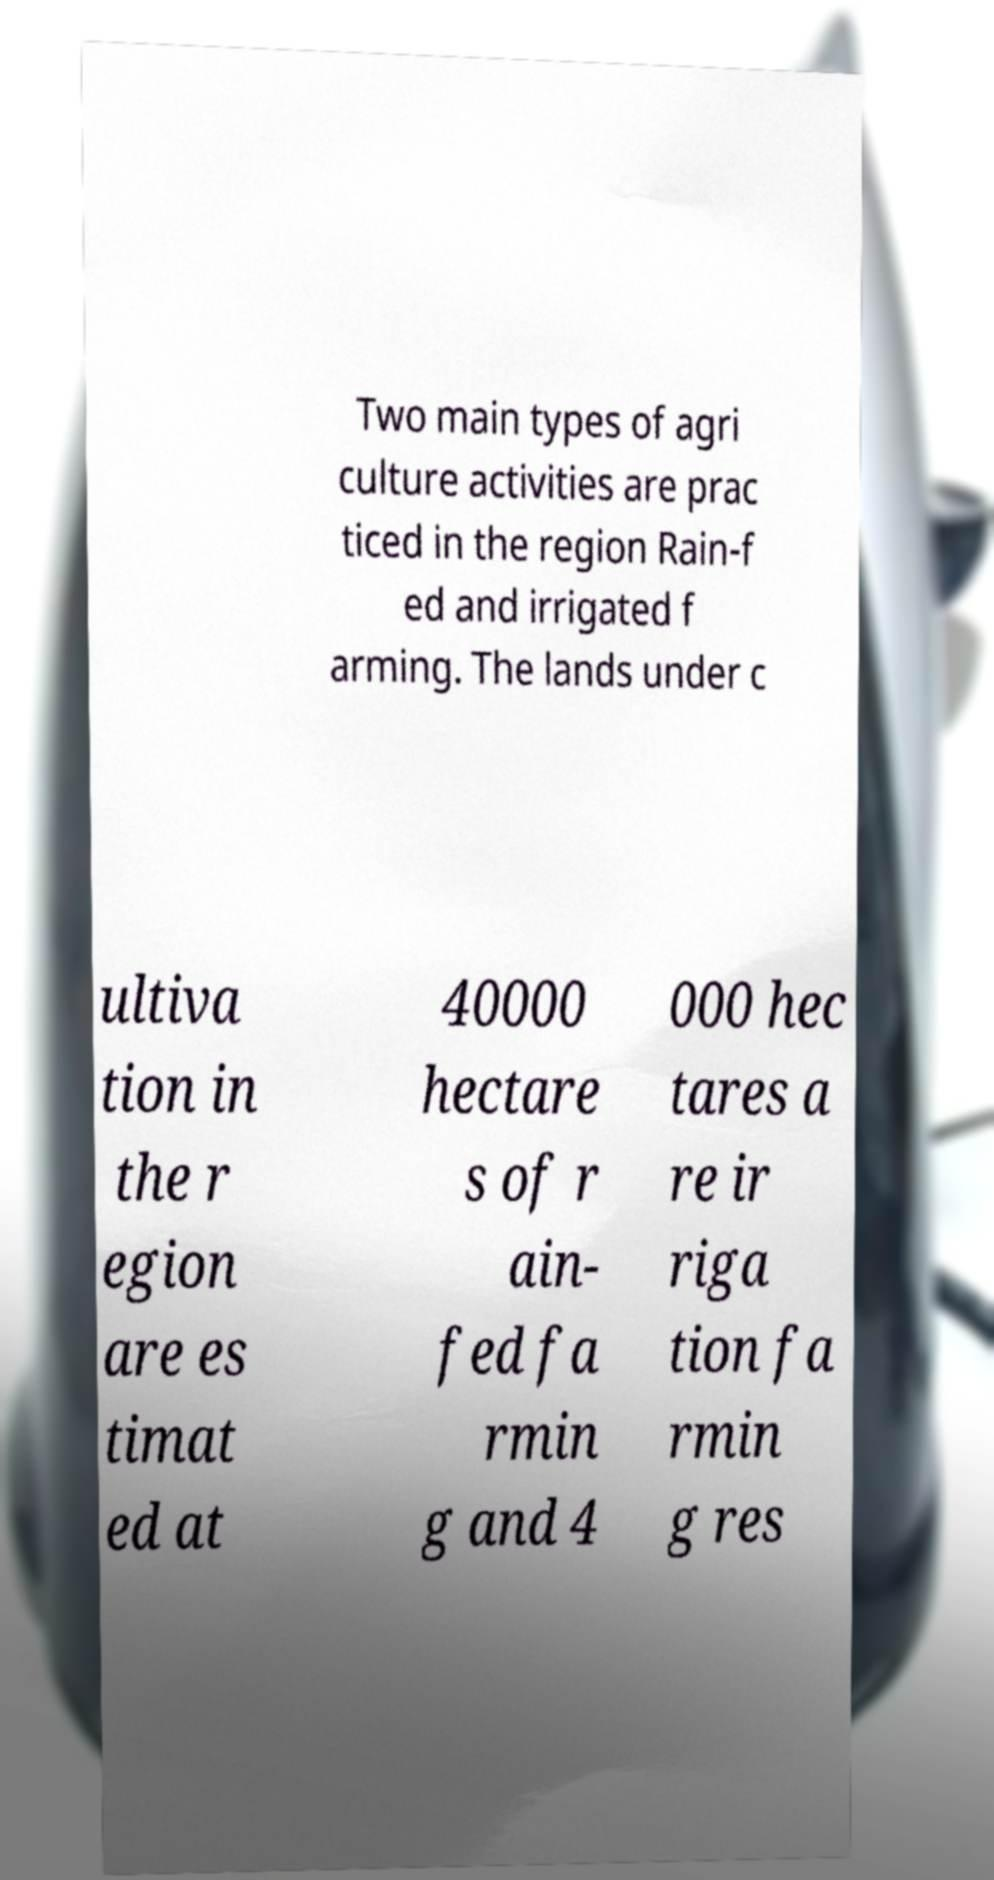Please read and relay the text visible in this image. What does it say? Two main types of agri culture activities are prac ticed in the region Rain-f ed and irrigated f arming. The lands under c ultiva tion in the r egion are es timat ed at 40000 hectare s of r ain- fed fa rmin g and 4 000 hec tares a re ir riga tion fa rmin g res 